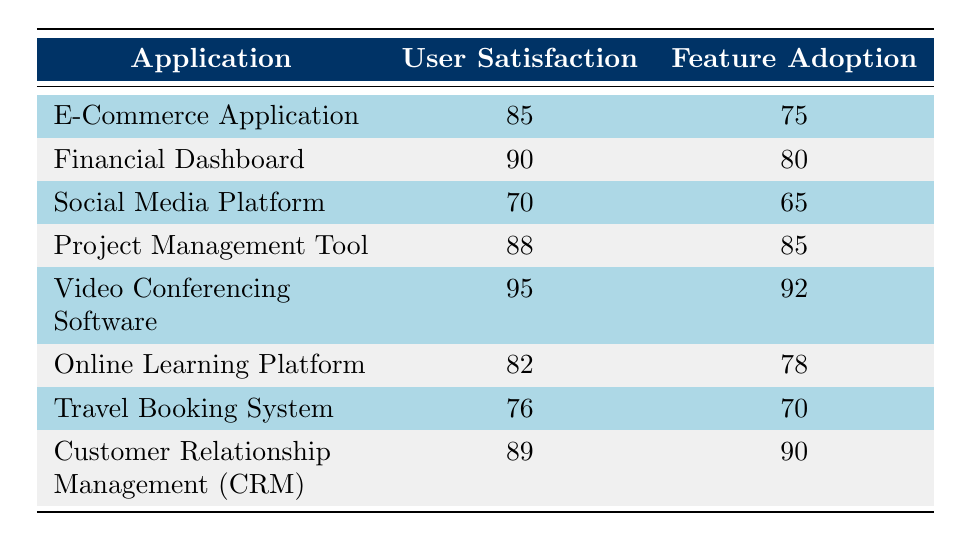What is the user satisfaction rating of the Video Conferencing Software? The table clearly lists the user satisfaction rating for the Video Conferencing Software as 95.
Answer: 95 What is the feature adoption rate of the Customer Relationship Management application? From the table, the feature adoption rate of the Customer Relationship Management application is shown to be 90.
Answer: 90 Which application has the lowest user satisfaction rating? By examining the user satisfaction ratings listed in the table, the Social Media Platform has the lowest rating at 70.
Answer: Social Media Platform What is the average user satisfaction rating of all applications listed? The user satisfaction ratings are 85, 90, 70, 88, 95, 82, 76, and 89. Summing these values gives 695, and there are 8 applications, so the average is 695 divided by 8, which equals 86.875.
Answer: 86.88 Does the Project Management Tool have a higher feature adoption rate than the E-Commerce Application? The Project Management Tool has a feature adoption rate of 85, while the E-Commerce Application has a rate of 75. Since 85 is greater than 75, the answer is yes.
Answer: Yes What is the difference in user satisfaction ratings between the Financial Dashboard and the Online Learning Platform? The user satisfaction rating for the Financial Dashboard is 90, and for the Online Learning Platform, it is 82. The difference is calculated as 90 minus 82, which equals 8.
Answer: 8 Which application has the highest feature adoption rate, and how does it compare to the lowest? The highest feature adoption rate is 92 for the Video Conferencing Software, while the lowest is 65 for the Social Media Platform. The difference between the highest and lowest is 92 minus 65, which equals 27.
Answer: 27 Is it true that the Travel Booking System has a user satisfaction rating that is higher than the Online Learning Platform? The user satisfaction rating for the Travel Booking System is 76 and for the Online Learning Platform is 82. Since 76 is less than 82, the answer is false.
Answer: No 